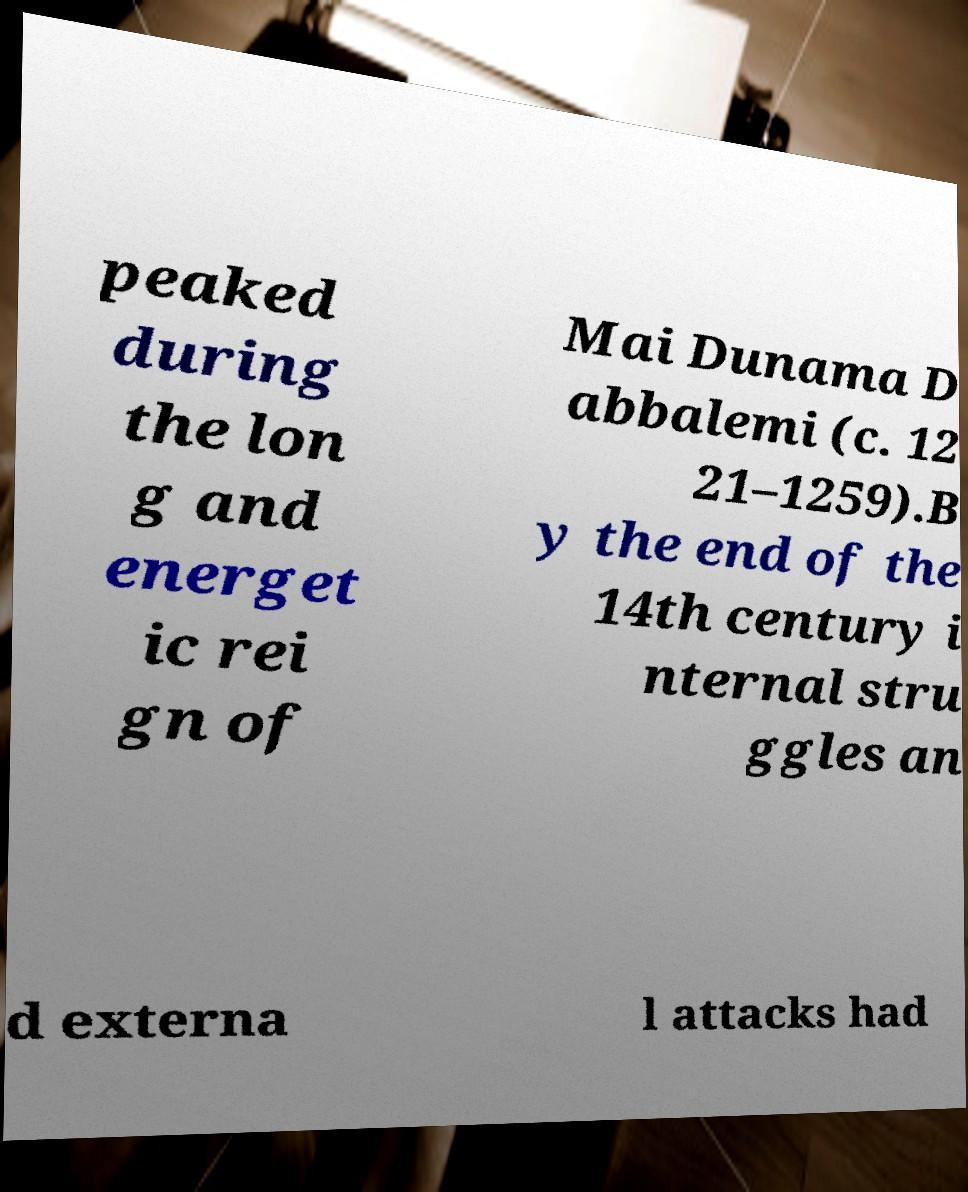Could you assist in decoding the text presented in this image and type it out clearly? peaked during the lon g and energet ic rei gn of Mai Dunama D abbalemi (c. 12 21–1259).B y the end of the 14th century i nternal stru ggles an d externa l attacks had 